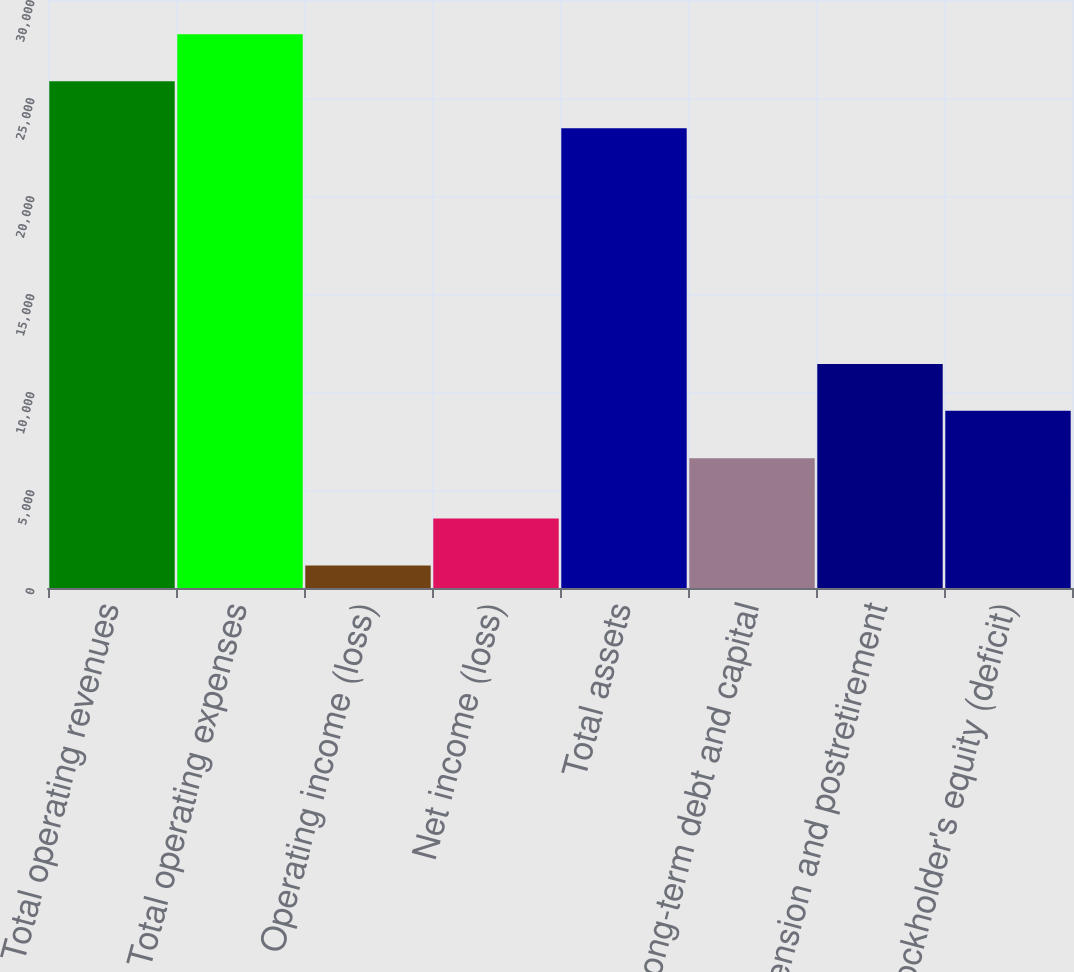Convert chart to OTSL. <chart><loc_0><loc_0><loc_500><loc_500><bar_chart><fcel>Total operating revenues<fcel>Total operating expenses<fcel>Operating income (loss)<fcel>Net income (loss)<fcel>Total assets<fcel>Long-term debt and capital<fcel>Pension and postretirement<fcel>Stockholder's equity (deficit)<nl><fcel>25855.7<fcel>28251.4<fcel>1154<fcel>3549.7<fcel>23460<fcel>6619<fcel>11432.7<fcel>9037<nl></chart> 